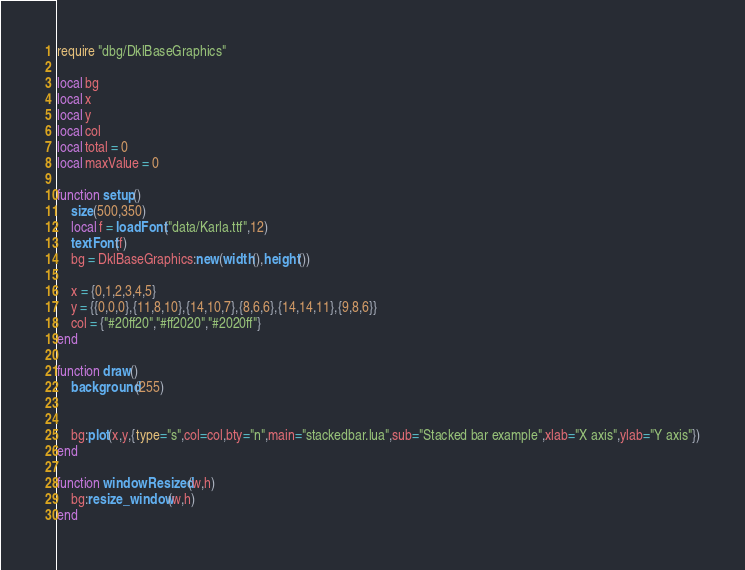<code> <loc_0><loc_0><loc_500><loc_500><_Lua_>require "dbg/DklBaseGraphics"

local bg
local x
local y
local col
local total = 0
local maxValue = 0

function setup()
	size(500,350)
	local f = loadFont("data/Karla.ttf",12)
	textFont(f)
	bg = DklBaseGraphics:new(width(),height())
	
	x = {0,1,2,3,4,5}
	y = {{0,0,0},{11,8,10},{14,10,7},{8,6,6},{14,14,11},{9,8,6}}
	col = {"#20ff20","#ff2020","#2020ff"}
end

function draw()
	background(255)
	

	bg:plot(x,y,{type="s",col=col,bty="n",main="stackedbar.lua",sub="Stacked bar example",xlab="X axis",ylab="Y axis"})
end

function windowResized(w,h)
	bg:resize_window(w,h)
end
</code> 